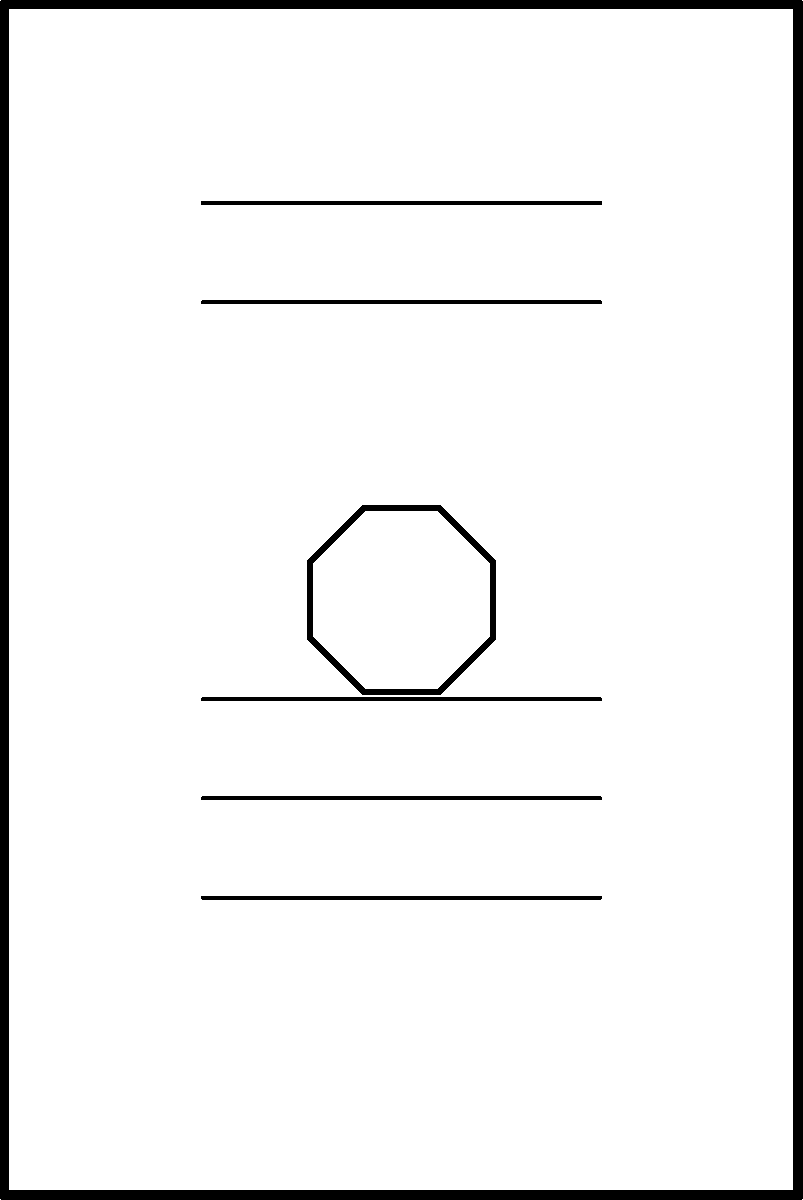Consider the cover design of a fantasy book as shown in the image. The design features a rectangular cover with a centered 8-pointed star and horizontal lines representing text. What is the order of the symmetry group for this design, assuming the text lines are indistinguishable? To determine the order of the symmetry group for this fantasy book cover design, let's analyze its symmetries step by step:

1. Rotational symmetry:
   - The 8-pointed star has 8-fold rotational symmetry.
   - However, the rectangular shape of the cover restricts this to 2-fold rotational symmetry (180° rotation).

2. Reflection symmetry:
   - Vertical reflection: The design is symmetric about the vertical line through the center.
   - Horizontal reflection: The design is symmetric about the horizontal line through the center.

3. Identity transformation:
   - The identity transformation (no change) is always a symmetry.

Now, let's count the symmetries:
- 1 identity transformation
- 1 180° rotation
- 1 vertical reflection
- 1 horizontal reflection

The total number of symmetries is 4. In group theory, the number of elements in a group is called its order.

Therefore, the symmetry group of this fantasy book cover design is isomorphic to the Klein four-group, denoted as $V_4$ or $C_2 \times C_2$, which has an order of 4.
Answer: 4 